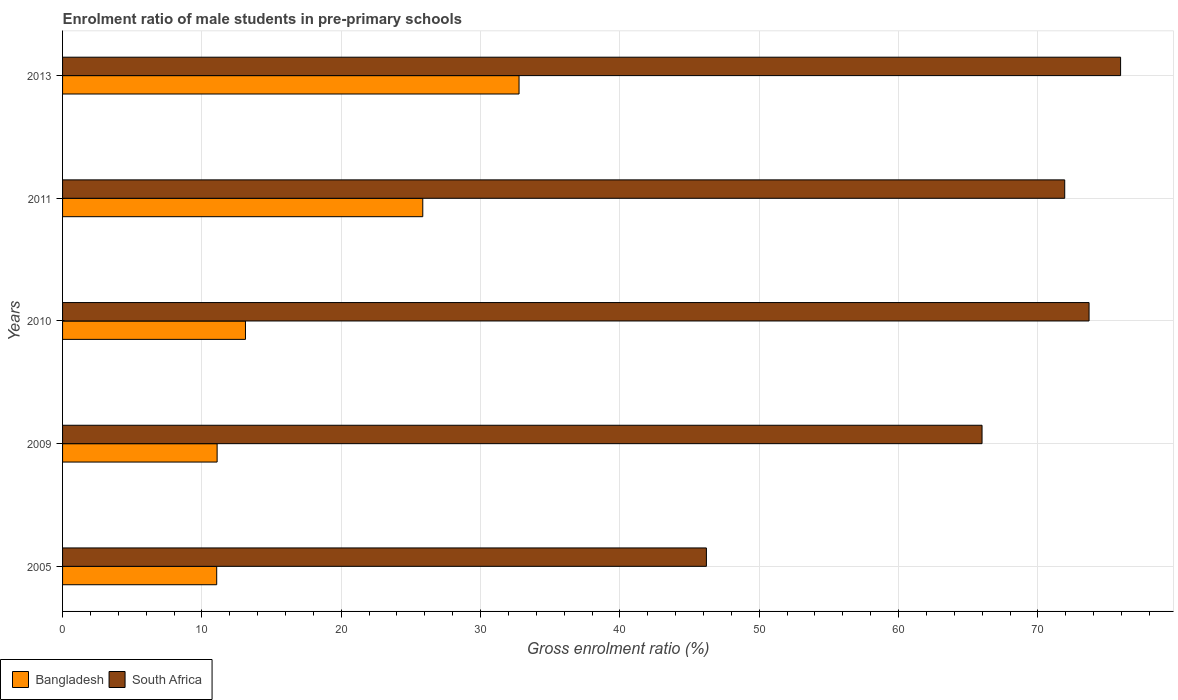How many groups of bars are there?
Keep it short and to the point. 5. Are the number of bars per tick equal to the number of legend labels?
Provide a succinct answer. Yes. How many bars are there on the 4th tick from the top?
Keep it short and to the point. 2. How many bars are there on the 2nd tick from the bottom?
Give a very brief answer. 2. What is the enrolment ratio of male students in pre-primary schools in South Africa in 2005?
Your answer should be compact. 46.21. Across all years, what is the maximum enrolment ratio of male students in pre-primary schools in Bangladesh?
Give a very brief answer. 32.76. Across all years, what is the minimum enrolment ratio of male students in pre-primary schools in Bangladesh?
Offer a terse response. 11.06. In which year was the enrolment ratio of male students in pre-primary schools in South Africa maximum?
Your answer should be compact. 2013. In which year was the enrolment ratio of male students in pre-primary schools in South Africa minimum?
Offer a very short reply. 2005. What is the total enrolment ratio of male students in pre-primary schools in South Africa in the graph?
Offer a terse response. 333.74. What is the difference between the enrolment ratio of male students in pre-primary schools in South Africa in 2005 and that in 2013?
Ensure brevity in your answer.  -29.73. What is the difference between the enrolment ratio of male students in pre-primary schools in South Africa in 2009 and the enrolment ratio of male students in pre-primary schools in Bangladesh in 2013?
Provide a succinct answer. 33.23. What is the average enrolment ratio of male students in pre-primary schools in Bangladesh per year?
Your answer should be very brief. 18.78. In the year 2009, what is the difference between the enrolment ratio of male students in pre-primary schools in Bangladesh and enrolment ratio of male students in pre-primary schools in South Africa?
Your answer should be compact. -54.9. What is the ratio of the enrolment ratio of male students in pre-primary schools in Bangladesh in 2005 to that in 2013?
Offer a terse response. 0.34. What is the difference between the highest and the second highest enrolment ratio of male students in pre-primary schools in South Africa?
Your answer should be very brief. 2.26. What is the difference between the highest and the lowest enrolment ratio of male students in pre-primary schools in Bangladesh?
Offer a terse response. 21.7. In how many years, is the enrolment ratio of male students in pre-primary schools in Bangladesh greater than the average enrolment ratio of male students in pre-primary schools in Bangladesh taken over all years?
Offer a very short reply. 2. What does the 1st bar from the top in 2010 represents?
Your answer should be compact. South Africa. What is the difference between two consecutive major ticks on the X-axis?
Your response must be concise. 10. Are the values on the major ticks of X-axis written in scientific E-notation?
Give a very brief answer. No. Does the graph contain any zero values?
Offer a terse response. No. Does the graph contain grids?
Provide a succinct answer. Yes. How many legend labels are there?
Provide a succinct answer. 2. What is the title of the graph?
Your answer should be very brief. Enrolment ratio of male students in pre-primary schools. What is the label or title of the X-axis?
Make the answer very short. Gross enrolment ratio (%). What is the label or title of the Y-axis?
Keep it short and to the point. Years. What is the Gross enrolment ratio (%) of Bangladesh in 2005?
Keep it short and to the point. 11.06. What is the Gross enrolment ratio (%) of South Africa in 2005?
Give a very brief answer. 46.21. What is the Gross enrolment ratio (%) in Bangladesh in 2009?
Your answer should be compact. 11.09. What is the Gross enrolment ratio (%) in South Africa in 2009?
Make the answer very short. 65.99. What is the Gross enrolment ratio (%) in Bangladesh in 2010?
Make the answer very short. 13.13. What is the Gross enrolment ratio (%) of South Africa in 2010?
Offer a terse response. 73.67. What is the Gross enrolment ratio (%) in Bangladesh in 2011?
Your answer should be very brief. 25.85. What is the Gross enrolment ratio (%) of South Africa in 2011?
Give a very brief answer. 71.93. What is the Gross enrolment ratio (%) in Bangladesh in 2013?
Your answer should be compact. 32.76. What is the Gross enrolment ratio (%) in South Africa in 2013?
Provide a succinct answer. 75.94. Across all years, what is the maximum Gross enrolment ratio (%) of Bangladesh?
Provide a succinct answer. 32.76. Across all years, what is the maximum Gross enrolment ratio (%) in South Africa?
Make the answer very short. 75.94. Across all years, what is the minimum Gross enrolment ratio (%) of Bangladesh?
Your answer should be compact. 11.06. Across all years, what is the minimum Gross enrolment ratio (%) in South Africa?
Keep it short and to the point. 46.21. What is the total Gross enrolment ratio (%) of Bangladesh in the graph?
Your answer should be compact. 93.9. What is the total Gross enrolment ratio (%) of South Africa in the graph?
Make the answer very short. 333.74. What is the difference between the Gross enrolment ratio (%) of Bangladesh in 2005 and that in 2009?
Your answer should be very brief. -0.03. What is the difference between the Gross enrolment ratio (%) in South Africa in 2005 and that in 2009?
Offer a very short reply. -19.78. What is the difference between the Gross enrolment ratio (%) in Bangladesh in 2005 and that in 2010?
Keep it short and to the point. -2.06. What is the difference between the Gross enrolment ratio (%) in South Africa in 2005 and that in 2010?
Offer a very short reply. -27.46. What is the difference between the Gross enrolment ratio (%) in Bangladesh in 2005 and that in 2011?
Provide a short and direct response. -14.79. What is the difference between the Gross enrolment ratio (%) of South Africa in 2005 and that in 2011?
Offer a terse response. -25.72. What is the difference between the Gross enrolment ratio (%) in Bangladesh in 2005 and that in 2013?
Your response must be concise. -21.7. What is the difference between the Gross enrolment ratio (%) of South Africa in 2005 and that in 2013?
Your answer should be very brief. -29.73. What is the difference between the Gross enrolment ratio (%) in Bangladesh in 2009 and that in 2010?
Ensure brevity in your answer.  -2.03. What is the difference between the Gross enrolment ratio (%) in South Africa in 2009 and that in 2010?
Your answer should be compact. -7.68. What is the difference between the Gross enrolment ratio (%) in Bangladesh in 2009 and that in 2011?
Offer a terse response. -14.76. What is the difference between the Gross enrolment ratio (%) in South Africa in 2009 and that in 2011?
Make the answer very short. -5.93. What is the difference between the Gross enrolment ratio (%) in Bangladesh in 2009 and that in 2013?
Ensure brevity in your answer.  -21.67. What is the difference between the Gross enrolment ratio (%) of South Africa in 2009 and that in 2013?
Provide a short and direct response. -9.94. What is the difference between the Gross enrolment ratio (%) of Bangladesh in 2010 and that in 2011?
Keep it short and to the point. -12.73. What is the difference between the Gross enrolment ratio (%) in South Africa in 2010 and that in 2011?
Your answer should be very brief. 1.75. What is the difference between the Gross enrolment ratio (%) of Bangladesh in 2010 and that in 2013?
Make the answer very short. -19.64. What is the difference between the Gross enrolment ratio (%) of South Africa in 2010 and that in 2013?
Provide a short and direct response. -2.26. What is the difference between the Gross enrolment ratio (%) in Bangladesh in 2011 and that in 2013?
Your answer should be compact. -6.91. What is the difference between the Gross enrolment ratio (%) of South Africa in 2011 and that in 2013?
Ensure brevity in your answer.  -4.01. What is the difference between the Gross enrolment ratio (%) in Bangladesh in 2005 and the Gross enrolment ratio (%) in South Africa in 2009?
Keep it short and to the point. -54.93. What is the difference between the Gross enrolment ratio (%) of Bangladesh in 2005 and the Gross enrolment ratio (%) of South Africa in 2010?
Keep it short and to the point. -62.61. What is the difference between the Gross enrolment ratio (%) of Bangladesh in 2005 and the Gross enrolment ratio (%) of South Africa in 2011?
Offer a terse response. -60.86. What is the difference between the Gross enrolment ratio (%) of Bangladesh in 2005 and the Gross enrolment ratio (%) of South Africa in 2013?
Keep it short and to the point. -64.87. What is the difference between the Gross enrolment ratio (%) of Bangladesh in 2009 and the Gross enrolment ratio (%) of South Africa in 2010?
Offer a terse response. -62.58. What is the difference between the Gross enrolment ratio (%) in Bangladesh in 2009 and the Gross enrolment ratio (%) in South Africa in 2011?
Your answer should be compact. -60.83. What is the difference between the Gross enrolment ratio (%) in Bangladesh in 2009 and the Gross enrolment ratio (%) in South Africa in 2013?
Make the answer very short. -64.84. What is the difference between the Gross enrolment ratio (%) of Bangladesh in 2010 and the Gross enrolment ratio (%) of South Africa in 2011?
Your answer should be very brief. -58.8. What is the difference between the Gross enrolment ratio (%) of Bangladesh in 2010 and the Gross enrolment ratio (%) of South Africa in 2013?
Provide a short and direct response. -62.81. What is the difference between the Gross enrolment ratio (%) of Bangladesh in 2011 and the Gross enrolment ratio (%) of South Africa in 2013?
Keep it short and to the point. -50.08. What is the average Gross enrolment ratio (%) of Bangladesh per year?
Provide a short and direct response. 18.78. What is the average Gross enrolment ratio (%) of South Africa per year?
Make the answer very short. 66.75. In the year 2005, what is the difference between the Gross enrolment ratio (%) of Bangladesh and Gross enrolment ratio (%) of South Africa?
Offer a very short reply. -35.15. In the year 2009, what is the difference between the Gross enrolment ratio (%) in Bangladesh and Gross enrolment ratio (%) in South Africa?
Give a very brief answer. -54.9. In the year 2010, what is the difference between the Gross enrolment ratio (%) in Bangladesh and Gross enrolment ratio (%) in South Africa?
Your answer should be very brief. -60.55. In the year 2011, what is the difference between the Gross enrolment ratio (%) of Bangladesh and Gross enrolment ratio (%) of South Africa?
Give a very brief answer. -46.07. In the year 2013, what is the difference between the Gross enrolment ratio (%) in Bangladesh and Gross enrolment ratio (%) in South Africa?
Offer a terse response. -43.17. What is the ratio of the Gross enrolment ratio (%) of South Africa in 2005 to that in 2009?
Ensure brevity in your answer.  0.7. What is the ratio of the Gross enrolment ratio (%) in Bangladesh in 2005 to that in 2010?
Your answer should be very brief. 0.84. What is the ratio of the Gross enrolment ratio (%) of South Africa in 2005 to that in 2010?
Your response must be concise. 0.63. What is the ratio of the Gross enrolment ratio (%) of Bangladesh in 2005 to that in 2011?
Make the answer very short. 0.43. What is the ratio of the Gross enrolment ratio (%) in South Africa in 2005 to that in 2011?
Provide a short and direct response. 0.64. What is the ratio of the Gross enrolment ratio (%) of Bangladesh in 2005 to that in 2013?
Give a very brief answer. 0.34. What is the ratio of the Gross enrolment ratio (%) of South Africa in 2005 to that in 2013?
Offer a very short reply. 0.61. What is the ratio of the Gross enrolment ratio (%) in Bangladesh in 2009 to that in 2010?
Make the answer very short. 0.85. What is the ratio of the Gross enrolment ratio (%) in South Africa in 2009 to that in 2010?
Offer a terse response. 0.9. What is the ratio of the Gross enrolment ratio (%) of Bangladesh in 2009 to that in 2011?
Make the answer very short. 0.43. What is the ratio of the Gross enrolment ratio (%) in South Africa in 2009 to that in 2011?
Ensure brevity in your answer.  0.92. What is the ratio of the Gross enrolment ratio (%) of Bangladesh in 2009 to that in 2013?
Ensure brevity in your answer.  0.34. What is the ratio of the Gross enrolment ratio (%) in South Africa in 2009 to that in 2013?
Provide a short and direct response. 0.87. What is the ratio of the Gross enrolment ratio (%) in Bangladesh in 2010 to that in 2011?
Provide a succinct answer. 0.51. What is the ratio of the Gross enrolment ratio (%) in South Africa in 2010 to that in 2011?
Give a very brief answer. 1.02. What is the ratio of the Gross enrolment ratio (%) in Bangladesh in 2010 to that in 2013?
Make the answer very short. 0.4. What is the ratio of the Gross enrolment ratio (%) of South Africa in 2010 to that in 2013?
Offer a terse response. 0.97. What is the ratio of the Gross enrolment ratio (%) of Bangladesh in 2011 to that in 2013?
Offer a terse response. 0.79. What is the ratio of the Gross enrolment ratio (%) of South Africa in 2011 to that in 2013?
Your answer should be very brief. 0.95. What is the difference between the highest and the second highest Gross enrolment ratio (%) in Bangladesh?
Provide a short and direct response. 6.91. What is the difference between the highest and the second highest Gross enrolment ratio (%) of South Africa?
Provide a short and direct response. 2.26. What is the difference between the highest and the lowest Gross enrolment ratio (%) of Bangladesh?
Provide a short and direct response. 21.7. What is the difference between the highest and the lowest Gross enrolment ratio (%) in South Africa?
Provide a short and direct response. 29.73. 